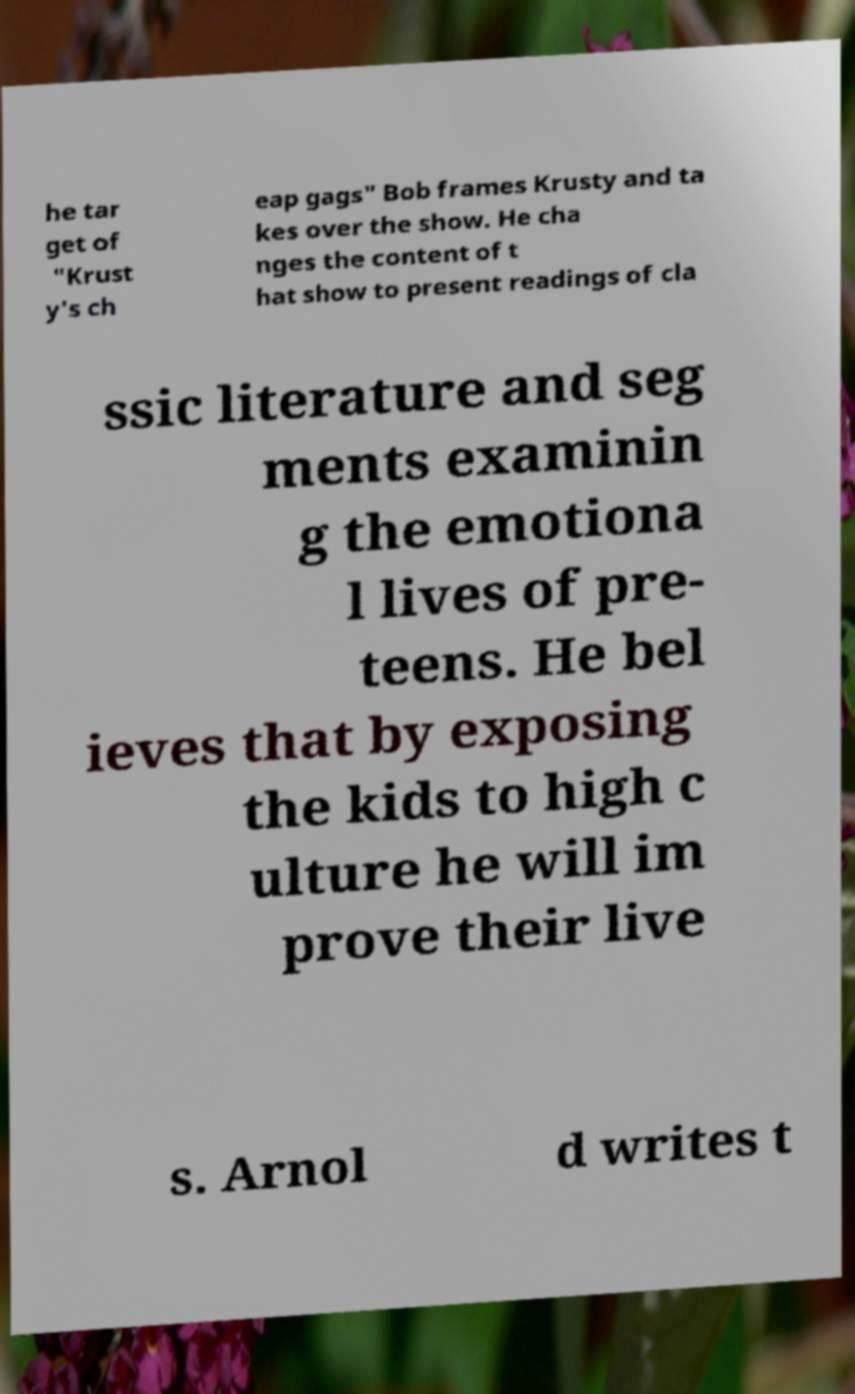Can you accurately transcribe the text from the provided image for me? he tar get of "Krust y's ch eap gags" Bob frames Krusty and ta kes over the show. He cha nges the content of t hat show to present readings of cla ssic literature and seg ments examinin g the emotiona l lives of pre- teens. He bel ieves that by exposing the kids to high c ulture he will im prove their live s. Arnol d writes t 